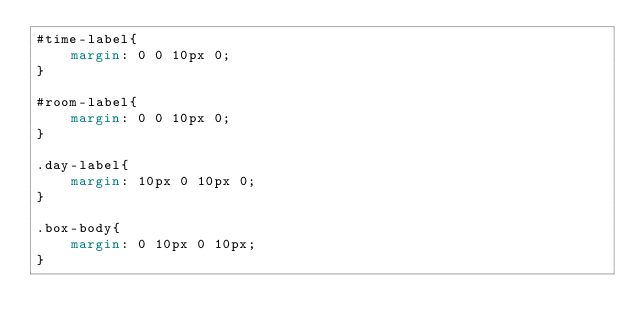Convert code to text. <code><loc_0><loc_0><loc_500><loc_500><_CSS_>#time-label{
	margin: 0 0 10px 0;
}

#room-label{
	margin: 0 0 10px 0;
}

.day-label{
	margin: 10px 0 10px 0;
}

.box-body{
	margin: 0 10px 0 10px;
}</code> 